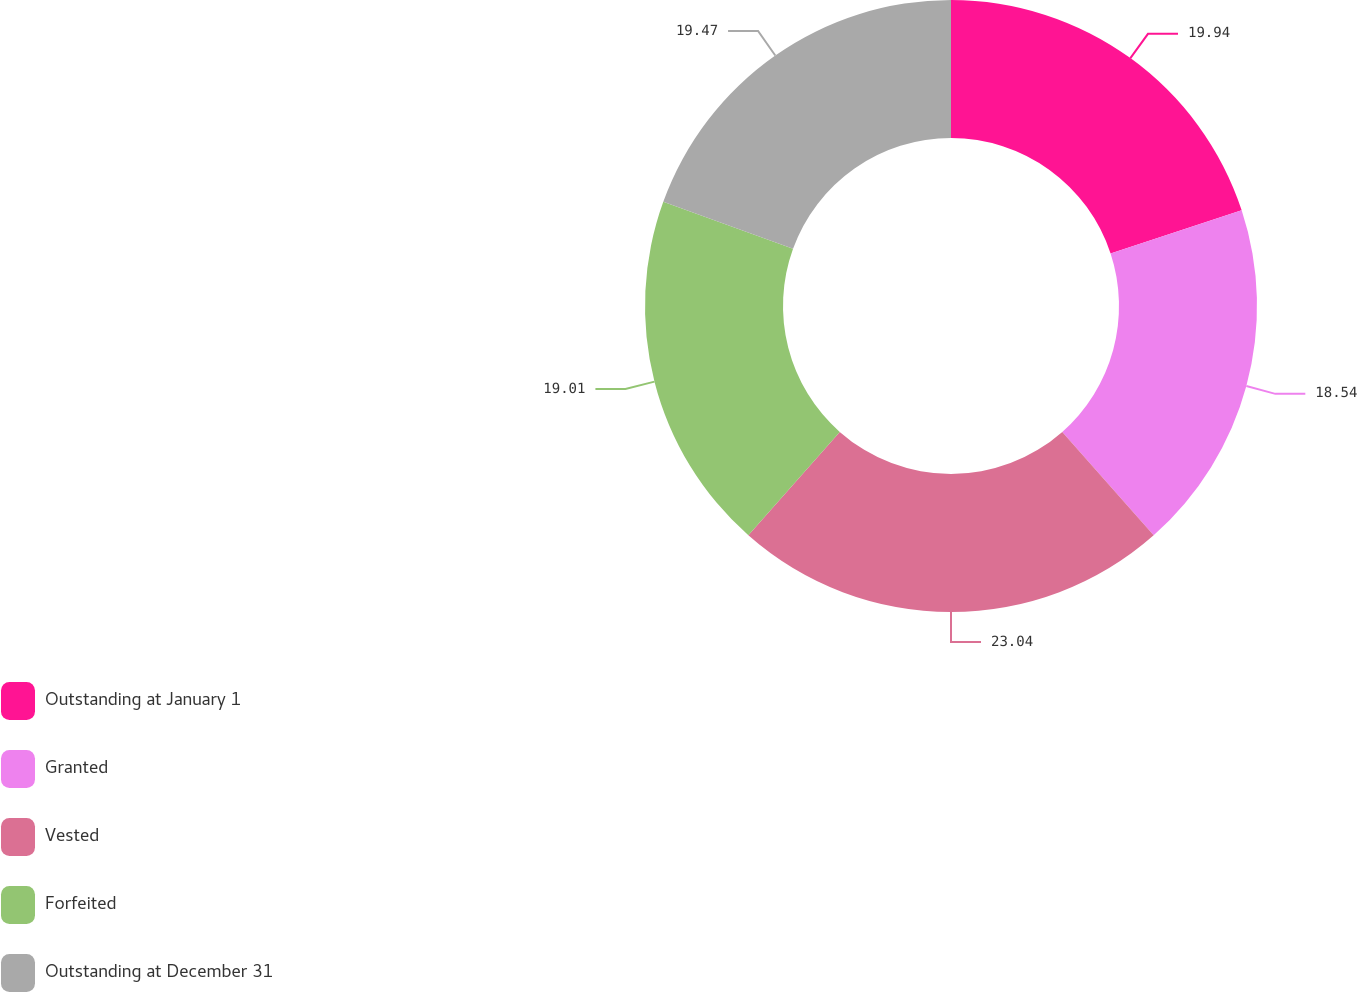Convert chart. <chart><loc_0><loc_0><loc_500><loc_500><pie_chart><fcel>Outstanding at January 1<fcel>Granted<fcel>Vested<fcel>Forfeited<fcel>Outstanding at December 31<nl><fcel>19.94%<fcel>18.54%<fcel>23.04%<fcel>19.01%<fcel>19.47%<nl></chart> 